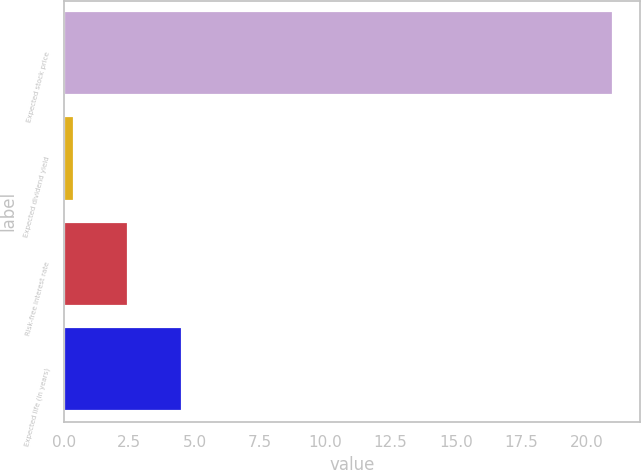Convert chart to OTSL. <chart><loc_0><loc_0><loc_500><loc_500><bar_chart><fcel>Expected stock price<fcel>Expected dividend yield<fcel>Risk-free interest rate<fcel>Expected life (in years)<nl><fcel>21<fcel>0.4<fcel>2.46<fcel>4.52<nl></chart> 